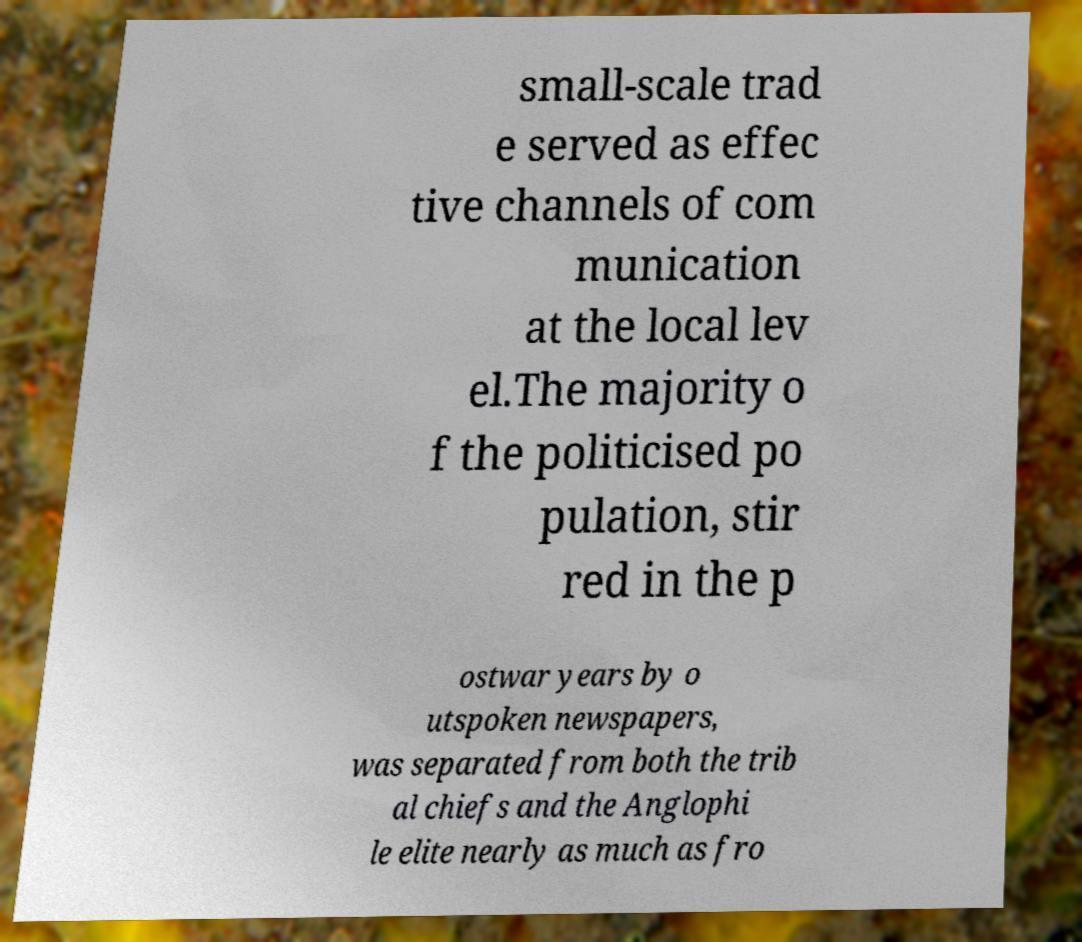For documentation purposes, I need the text within this image transcribed. Could you provide that? small-scale trad e served as effec tive channels of com munication at the local lev el.The majority o f the politicised po pulation, stir red in the p ostwar years by o utspoken newspapers, was separated from both the trib al chiefs and the Anglophi le elite nearly as much as fro 